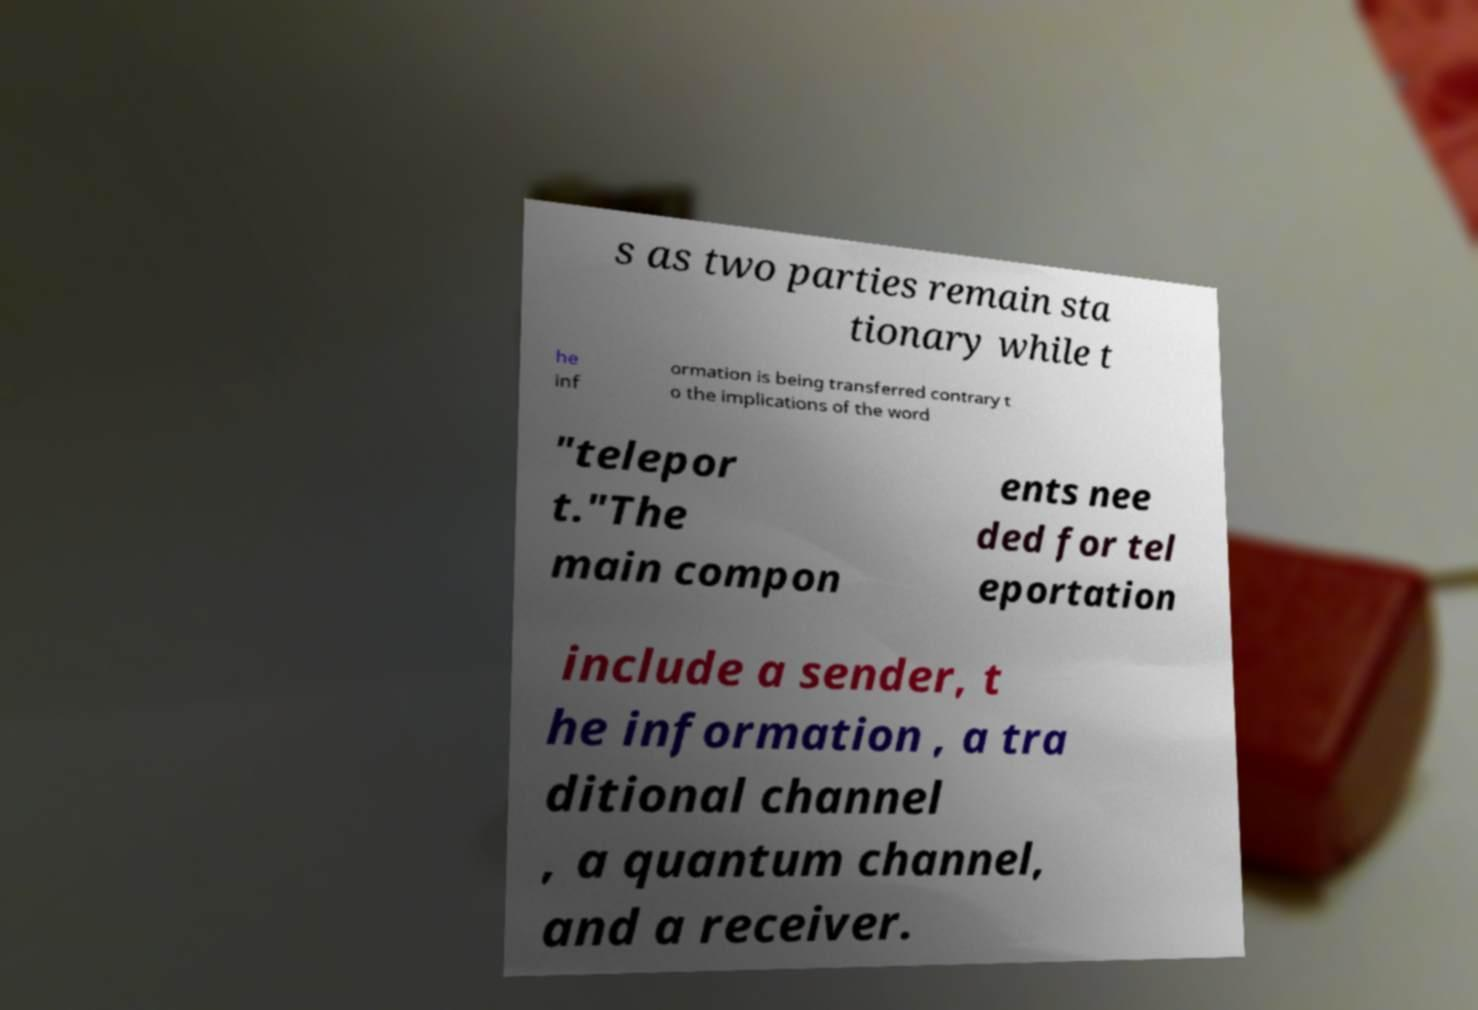Could you extract and type out the text from this image? s as two parties remain sta tionary while t he inf ormation is being transferred contrary t o the implications of the word "telepor t."The main compon ents nee ded for tel eportation include a sender, t he information , a tra ditional channel , a quantum channel, and a receiver. 